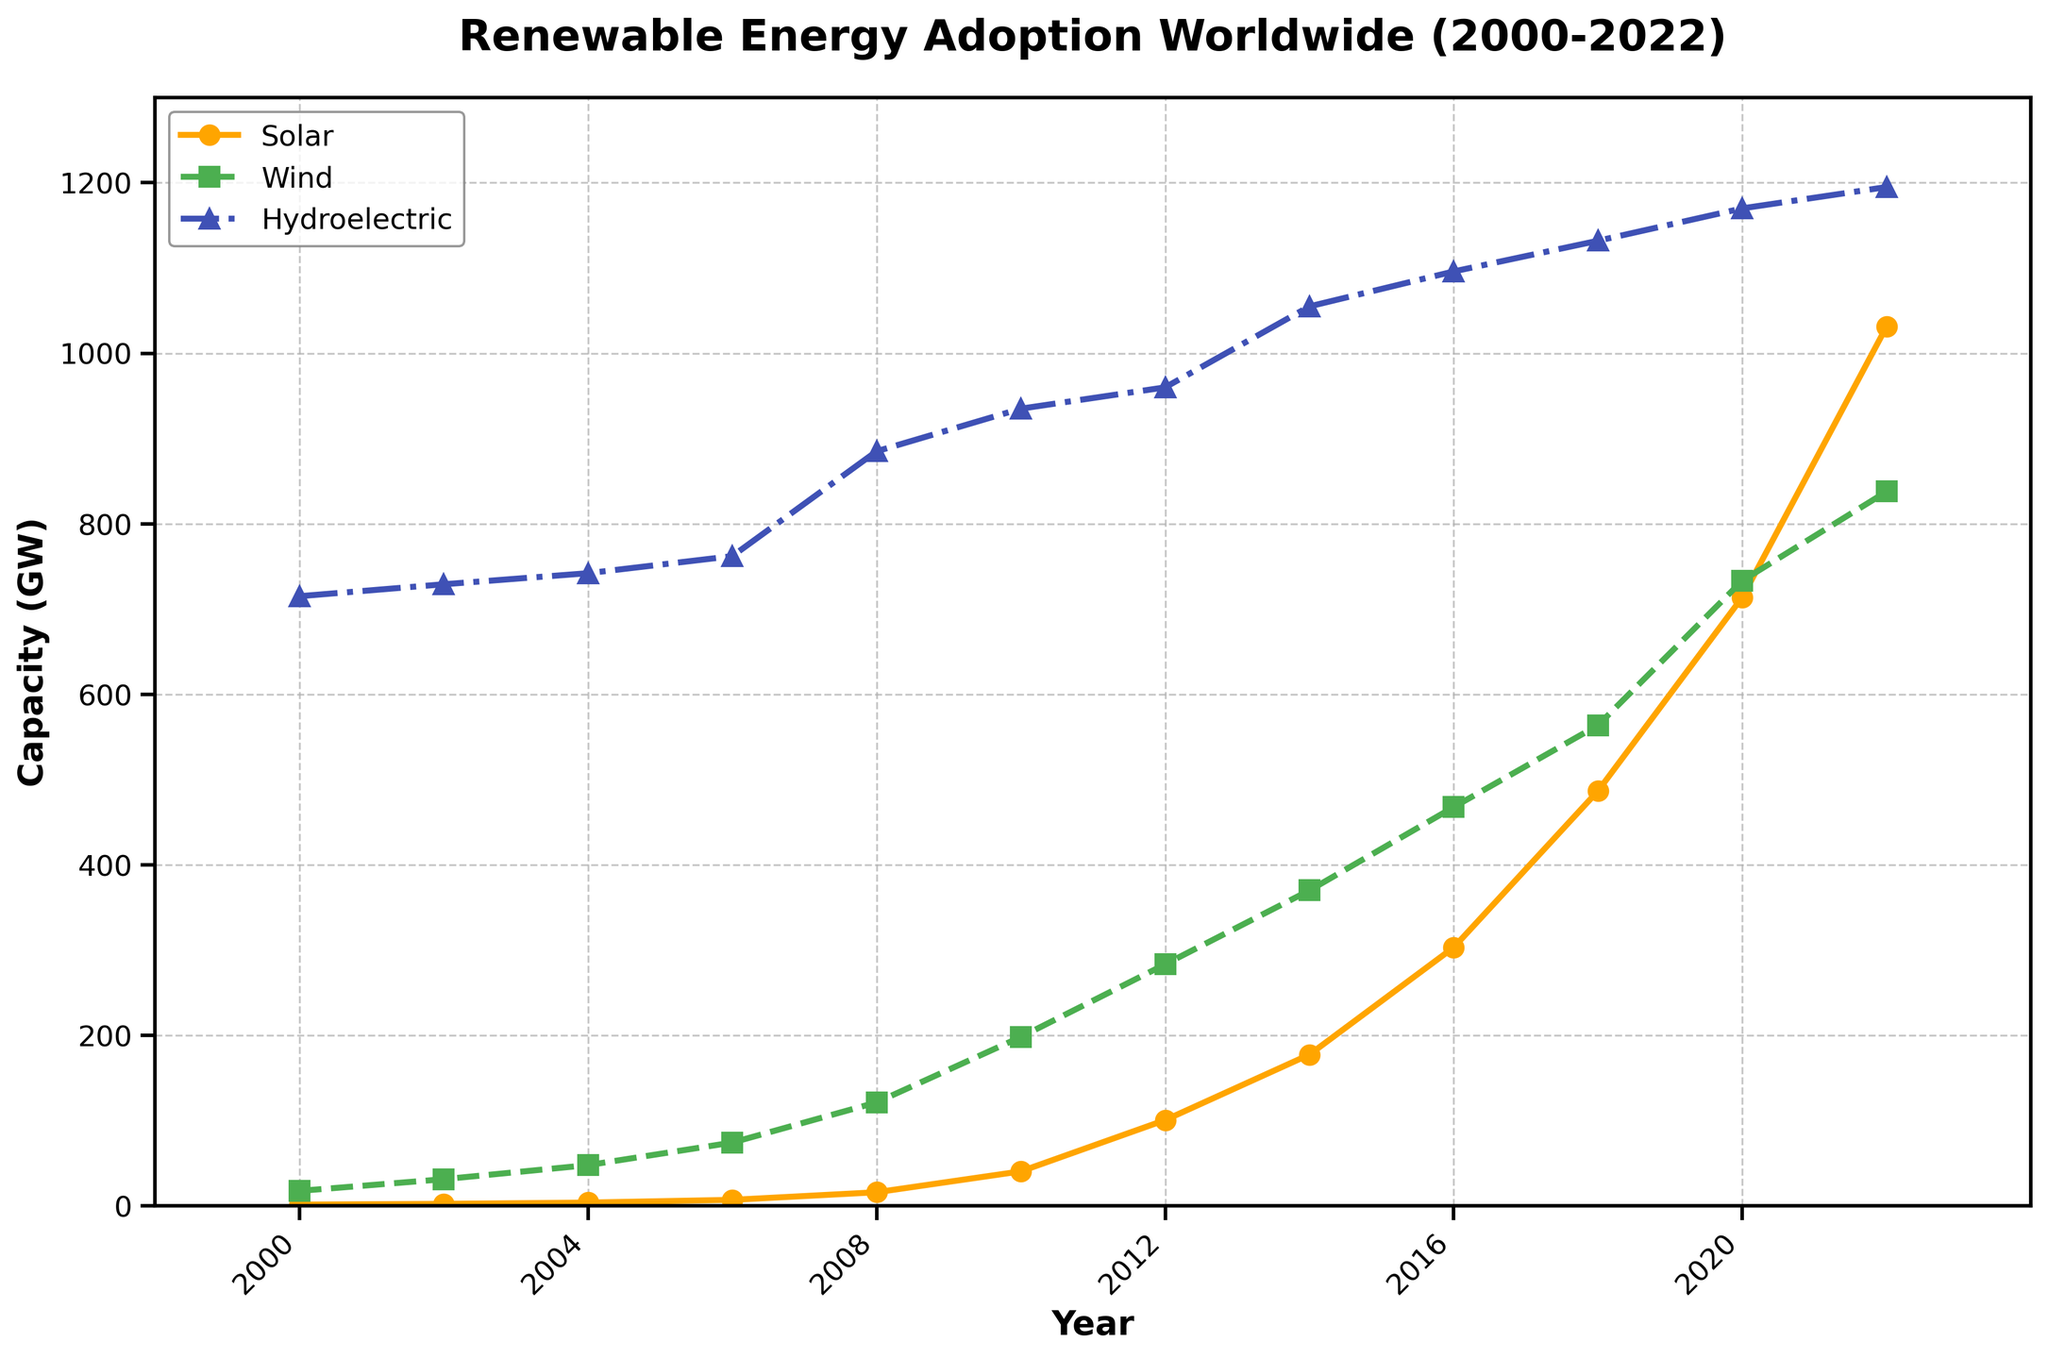What year did solar energy surpass 100 GW in capacity? The solar energy capacity surpassed 100 GW between 2010 and 2012. Looking at the data points, it reached 100.5 GW in 2012.
Answer: 2012 Between 2008 and 2012, which renewable energy sources saw the largest absolute increase in capacity? From 2008 to 2012, solar increased from 15.8 GW to 100.5 GW (an increase of 84.7 GW), wind increased from 121.2 GW to 283.2 GW (an increase of 162 GW), and hydro increased from 885 GW to 960 GW (an increase of 75 GW). The largest increase is in wind.
Answer: Wind How does the growth rate of solar energy from 2010 to 2020 compare to the growth rate of wind energy over the same period? Solar grew from 40.3 GW in 2010 to 713.9 GW in 2020, an increase of 673.6 GW. Wind grew from 198 GW in 2010 to 733.3 GW in 2020, an increase of 535.3 GW. Both saw significant growth, but solar had a higher total increase of 673.6 GW compared to 535.3 GW for wind.
Answer: Solar had a higher growth rate What was the capacity of wind energy in 2006 compared to hydroelectric energy in the same year? In 2006, wind energy had a capacity of 74.1 GW, while hydroelectric had a capacity of 762 GW.
Answer: Wind: 74.1 GW, Hydro: 762 GW In which year did wind energy surpass 500 GW in capacity? Wind energy surpassed 500 GW between 2014 and 2016. By 2016, the capacity was 467.7 GW, and it increased to 563.7 GW by 2018. It surpassed 500 GW in 2018.
Answer: 2018 Compare the visual representation of solar energy capacity to wind energy capacity in 2022. In 2022, solar energy is represented by a solid line with circular markers in orange, and wind energy is represented by a dashed line with square markers in green. Solar energy has a more significant increase in the slope, indicating a faster growth rate than wind energy.
Answer: Solar has a faster growth rate visually From 2000 to 2022, which renewable energy source has shown the most consistent linear growth? Observing the lines' slopes, hydroelectric energy shows the most consistent linear growth as indicated by its relatively steady upward trend. Solar and wind show more exponential growth patterns with increasing slopes over time.
Answer: Hydroelectric 